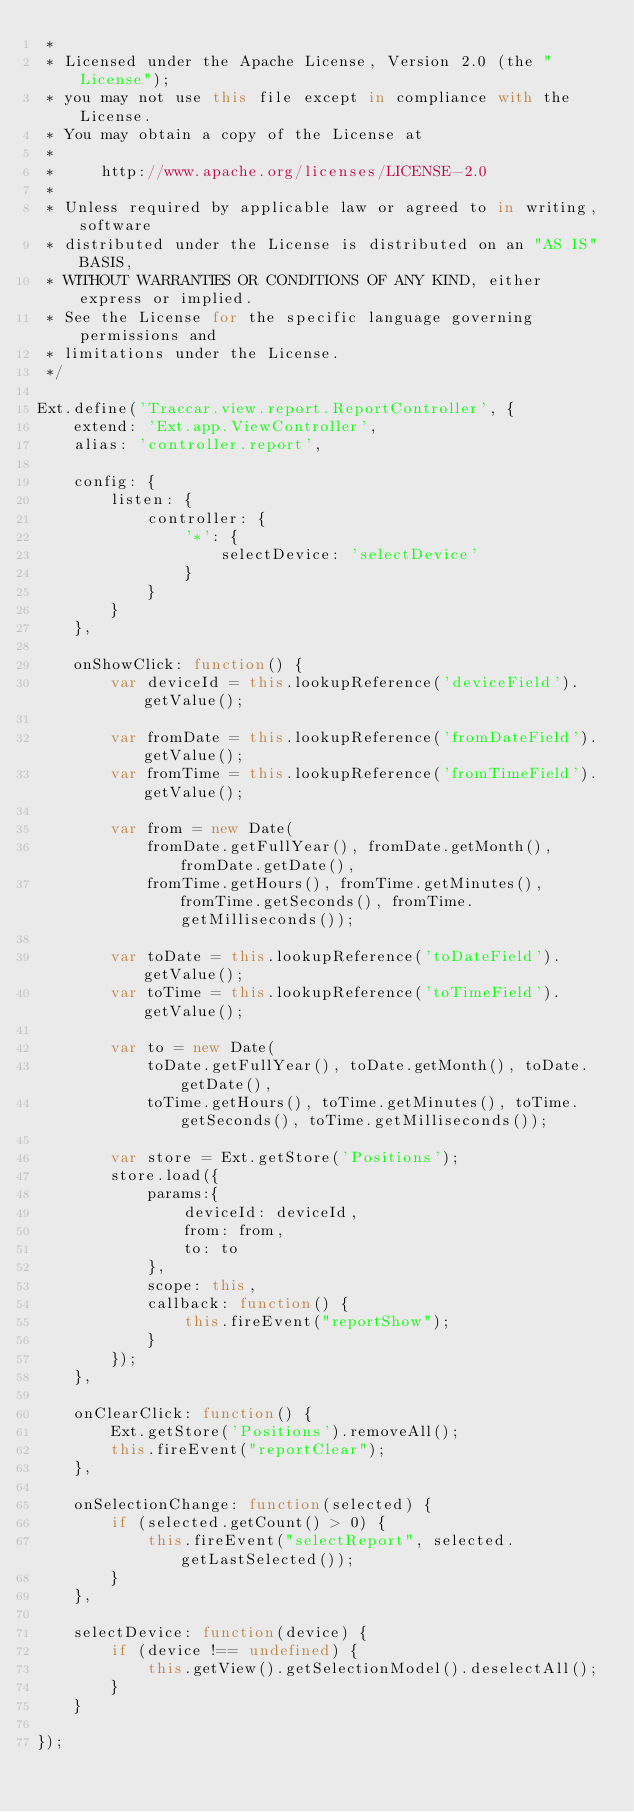Convert code to text. <code><loc_0><loc_0><loc_500><loc_500><_JavaScript_> *
 * Licensed under the Apache License, Version 2.0 (the "License");
 * you may not use this file except in compliance with the License.
 * You may obtain a copy of the License at
 *
 *     http://www.apache.org/licenses/LICENSE-2.0
 *
 * Unless required by applicable law or agreed to in writing, software
 * distributed under the License is distributed on an "AS IS" BASIS,
 * WITHOUT WARRANTIES OR CONDITIONS OF ANY KIND, either express or implied.
 * See the License for the specific language governing permissions and
 * limitations under the License.
 */

Ext.define('Traccar.view.report.ReportController', {
    extend: 'Ext.app.ViewController',
    alias: 'controller.report',

    config: {
        listen: {
            controller: {
                '*': {
                    selectDevice: 'selectDevice'
                }
            }
        }
    },

    onShowClick: function() {
        var deviceId = this.lookupReference('deviceField').getValue();

        var fromDate = this.lookupReference('fromDateField').getValue();
        var fromTime = this.lookupReference('fromTimeField').getValue();

        var from = new Date(
            fromDate.getFullYear(), fromDate.getMonth(), fromDate.getDate(),
            fromTime.getHours(), fromTime.getMinutes(), fromTime.getSeconds(), fromTime.getMilliseconds());

        var toDate = this.lookupReference('toDateField').getValue();
        var toTime = this.lookupReference('toTimeField').getValue();

        var to = new Date(
            toDate.getFullYear(), toDate.getMonth(), toDate.getDate(),
            toTime.getHours(), toTime.getMinutes(), toTime.getSeconds(), toTime.getMilliseconds());

        var store = Ext.getStore('Positions');
        store.load({
            params:{
                deviceId: deviceId,
                from: from,
                to: to
            },
            scope: this,
            callback: function() {
                this.fireEvent("reportShow");
            }
        });
    },

    onClearClick: function() {
        Ext.getStore('Positions').removeAll();
        this.fireEvent("reportClear");
    },

    onSelectionChange: function(selected) {
        if (selected.getCount() > 0) {
            this.fireEvent("selectReport", selected.getLastSelected());
        }
    },

    selectDevice: function(device) {
        if (device !== undefined) {
            this.getView().getSelectionModel().deselectAll();
        }
    }

});
</code> 